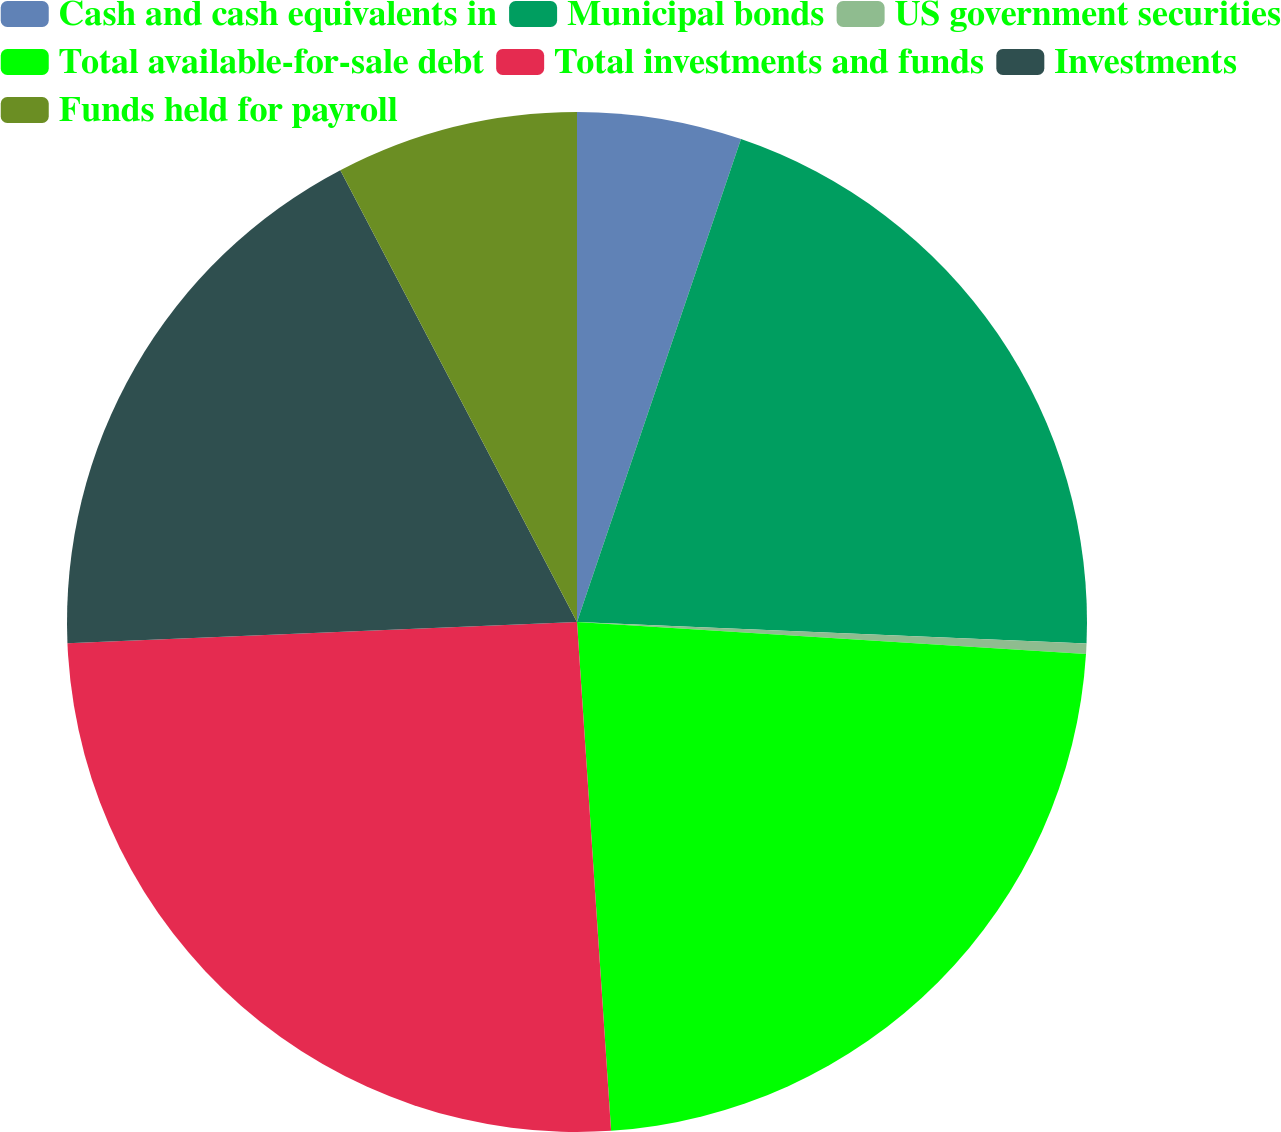<chart> <loc_0><loc_0><loc_500><loc_500><pie_chart><fcel>Cash and cash equivalents in<fcel>Municipal bonds<fcel>US government securities<fcel>Total available-for-sale debt<fcel>Total investments and funds<fcel>Investments<fcel>Funds held for payroll<nl><fcel>5.21%<fcel>20.46%<fcel>0.33%<fcel>22.93%<fcel>25.4%<fcel>17.98%<fcel>7.68%<nl></chart> 